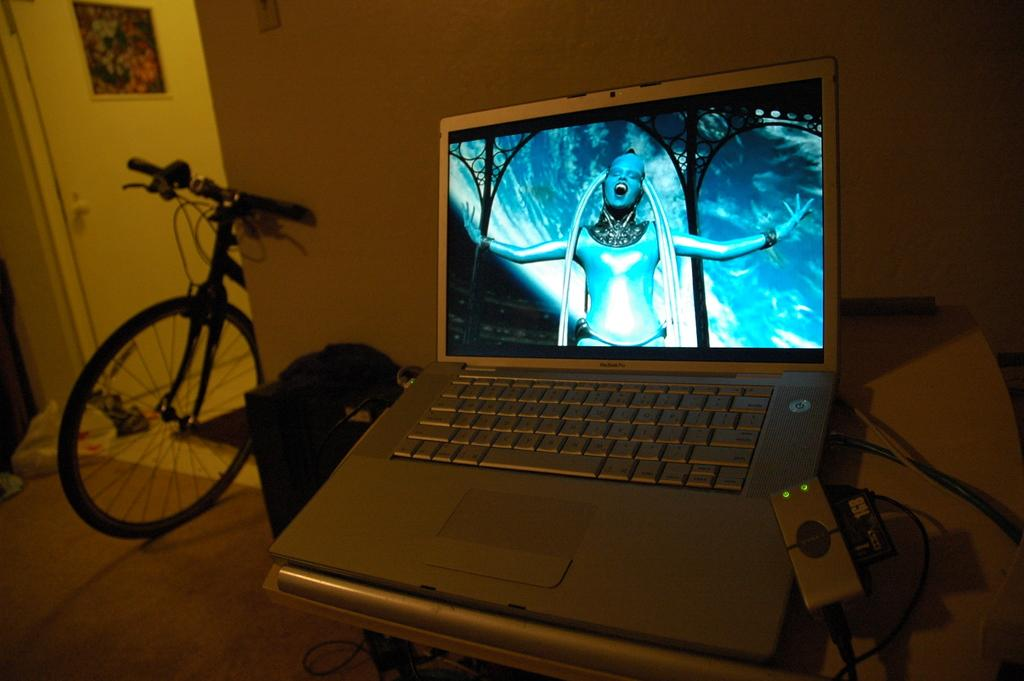What electronic device is on the table in the image? There is a laptop on the table in the image. What type of flooring is visible in the image? There is a carpet in the image. What mode of transportation can be seen in the image? There is a bicycle in the image. What is attached to the wall in the image? There is a frame attached to the wall. What type of gold jewelry is the daughter wearing in the image? There is no daughter or gold jewelry present in the image. How does the behavior of the bicycle change throughout the image? The image does not depict any behavior of the bicycle, as it is a static object. 